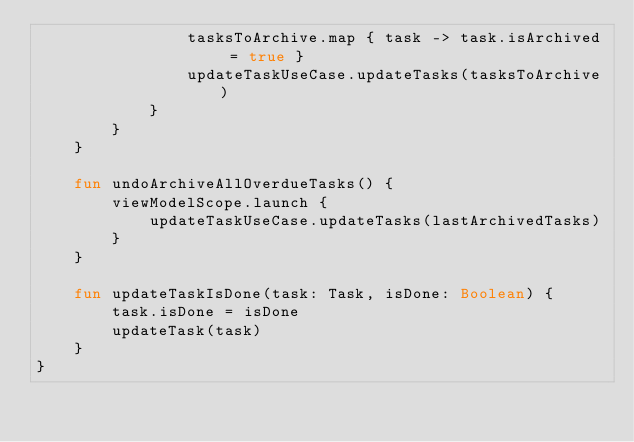<code> <loc_0><loc_0><loc_500><loc_500><_Kotlin_>                tasksToArchive.map { task -> task.isArchived = true }
                updateTaskUseCase.updateTasks(tasksToArchive)
            }
        }
    }

    fun undoArchiveAllOverdueTasks() {
        viewModelScope.launch {
            updateTaskUseCase.updateTasks(lastArchivedTasks)
        }
    }

    fun updateTaskIsDone(task: Task, isDone: Boolean) {
        task.isDone = isDone
        updateTask(task)
    }
}</code> 